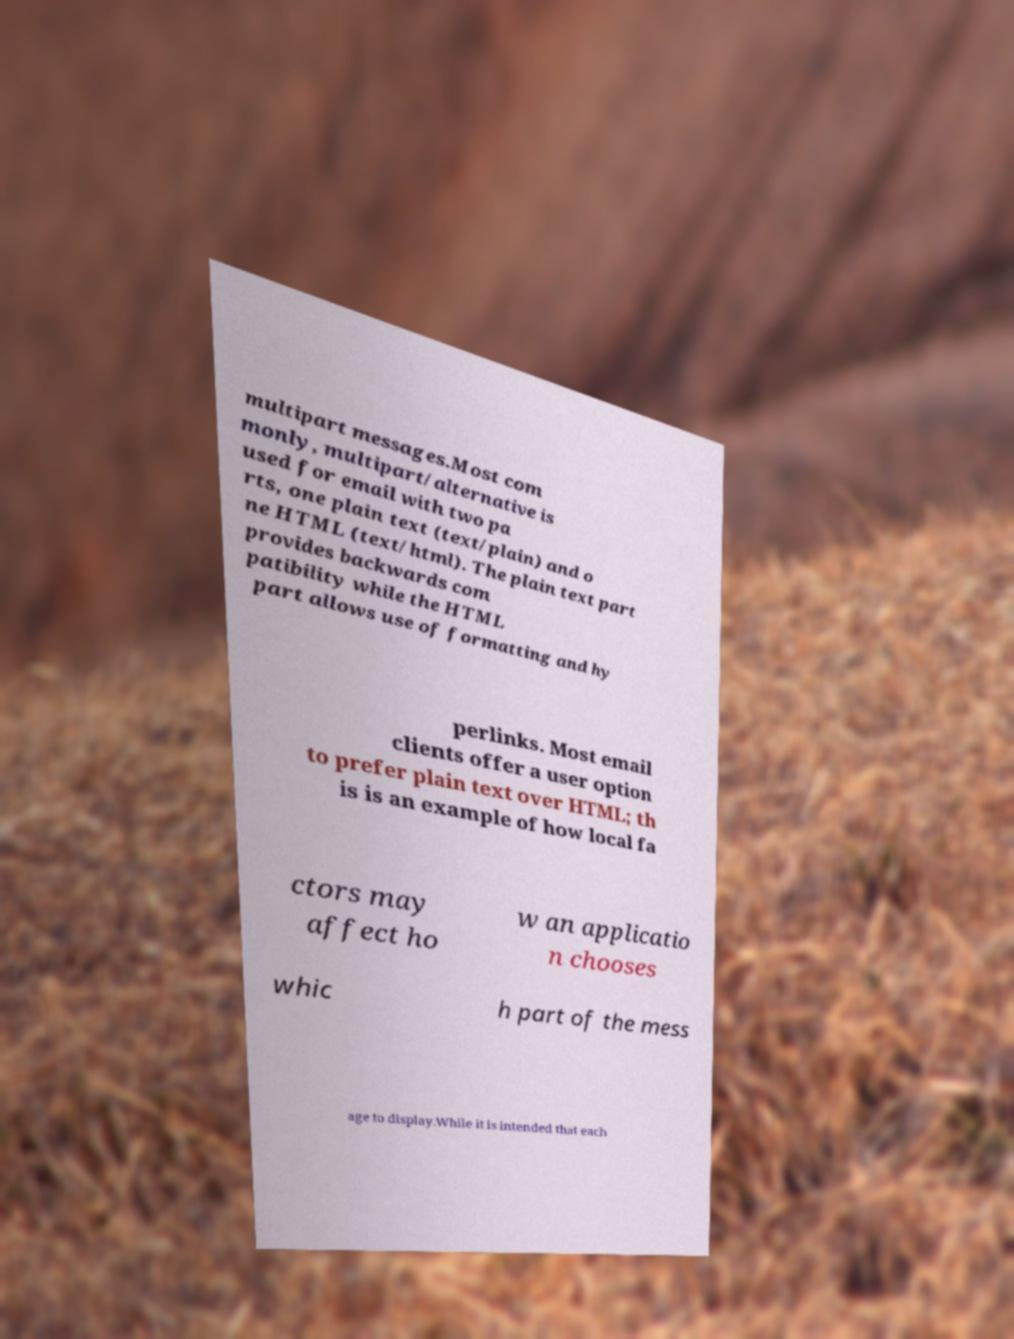Can you read and provide the text displayed in the image?This photo seems to have some interesting text. Can you extract and type it out for me? multipart messages.Most com monly, multipart/alternative is used for email with two pa rts, one plain text (text/plain) and o ne HTML (text/html). The plain text part provides backwards com patibility while the HTML part allows use of formatting and hy perlinks. Most email clients offer a user option to prefer plain text over HTML; th is is an example of how local fa ctors may affect ho w an applicatio n chooses whic h part of the mess age to display.While it is intended that each 